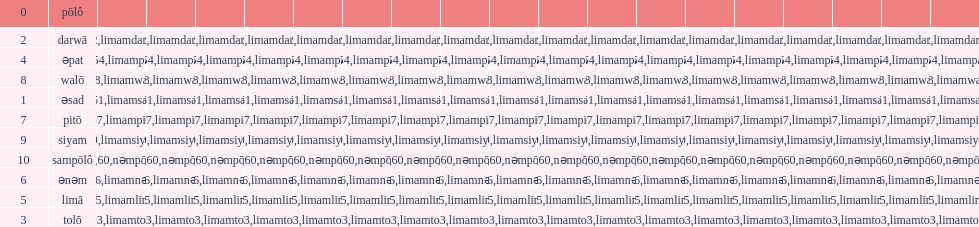In the rinconada bikol language, what is the last single digit integer? Siyam. 